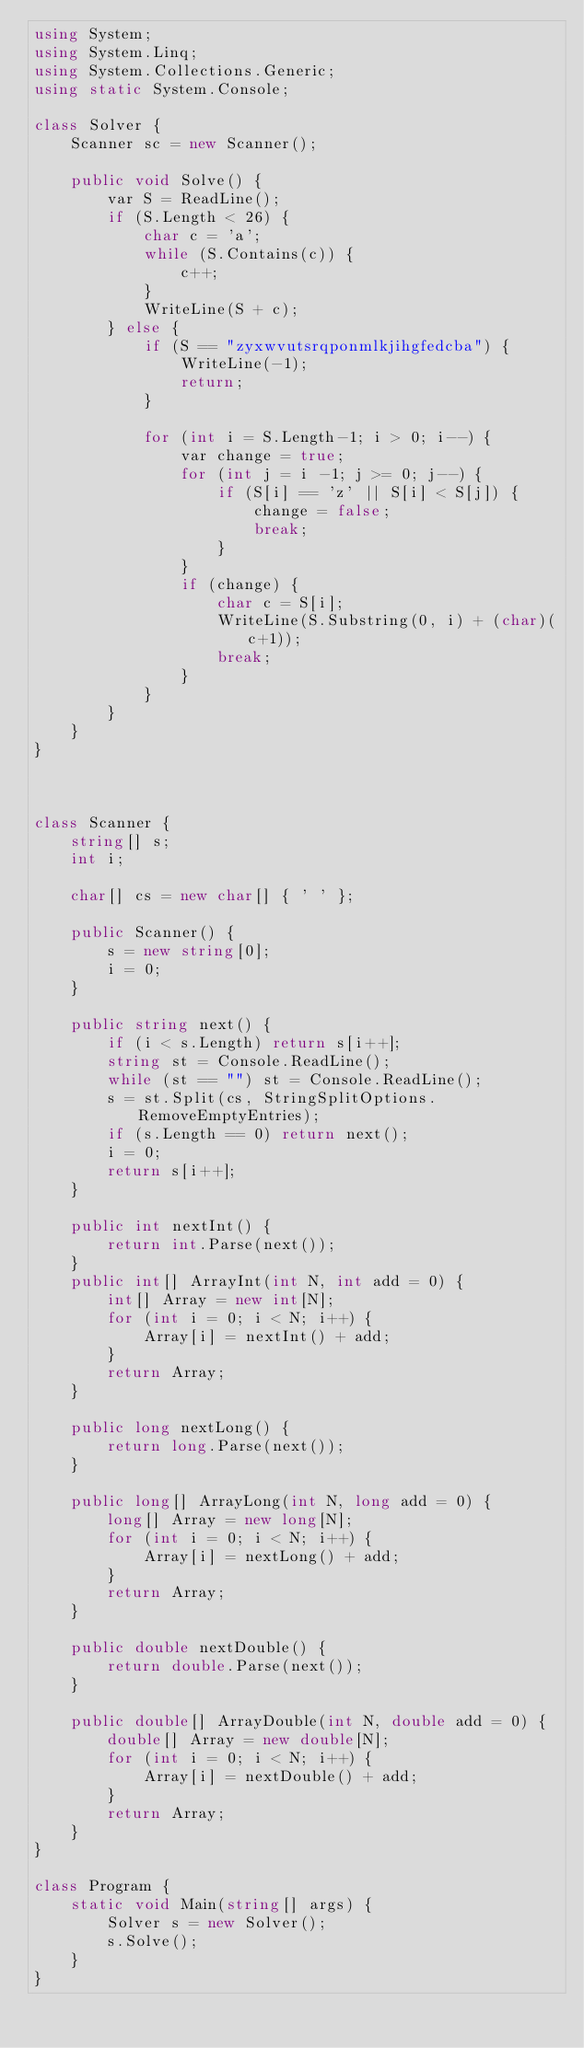Convert code to text. <code><loc_0><loc_0><loc_500><loc_500><_C#_>using System;
using System.Linq;
using System.Collections.Generic;
using static System.Console;

class Solver {
    Scanner sc = new Scanner();

    public void Solve() {
        var S = ReadLine();
        if (S.Length < 26) {
            char c = 'a';
            while (S.Contains(c)) {
                c++;
            }
            WriteLine(S + c);
        } else {
            if (S == "zyxwvutsrqponmlkjihgfedcba") {
                WriteLine(-1);
                return;
            }

            for (int i = S.Length-1; i > 0; i--) {
                var change = true;
                for (int j = i -1; j >= 0; j--) {
                    if (S[i] == 'z' || S[i] < S[j]) {
                        change = false;
                        break;
                    }
                }
                if (change) {
                    char c = S[i];
                    WriteLine(S.Substring(0, i) + (char)(c+1));
                    break;
                }
            }
        }
    }
}



class Scanner {
    string[] s;
    int i;

    char[] cs = new char[] { ' ' };

    public Scanner() {
        s = new string[0];
        i = 0;
    }

    public string next() {
        if (i < s.Length) return s[i++];
        string st = Console.ReadLine();
        while (st == "") st = Console.ReadLine();
        s = st.Split(cs, StringSplitOptions.RemoveEmptyEntries);
        if (s.Length == 0) return next();
        i = 0;
        return s[i++];
    }

    public int nextInt() {
        return int.Parse(next());
    }
    public int[] ArrayInt(int N, int add = 0) {
        int[] Array = new int[N];
        for (int i = 0; i < N; i++) {
            Array[i] = nextInt() + add;
        }
        return Array;
    }

    public long nextLong() {
        return long.Parse(next());
    }

    public long[] ArrayLong(int N, long add = 0) {
        long[] Array = new long[N];
        for (int i = 0; i < N; i++) {
            Array[i] = nextLong() + add;
        }
        return Array;
    }

    public double nextDouble() {
        return double.Parse(next());
    }

    public double[] ArrayDouble(int N, double add = 0) {
        double[] Array = new double[N];
        for (int i = 0; i < N; i++) {
            Array[i] = nextDouble() + add;
        }
        return Array;
    }
}

class Program {
    static void Main(string[] args) {
        Solver s = new Solver();
        s.Solve();
    }
}
</code> 